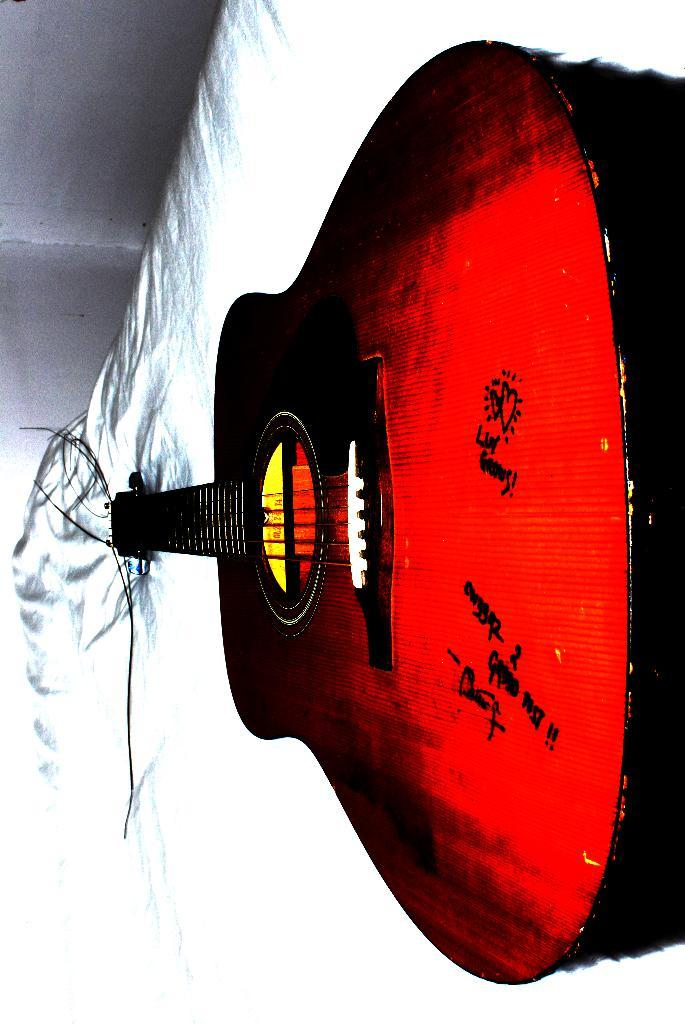What type of musical instrument is in the image? There is a red guitar in the image. Where is the red guitar located? The red guitar is on a bed. What can be seen in the background of the image? There is a wall visible in the background of the image. What type of friction can be observed between the guitar and the bed in the image? There is no friction observable between the guitar and the bed in the image. 